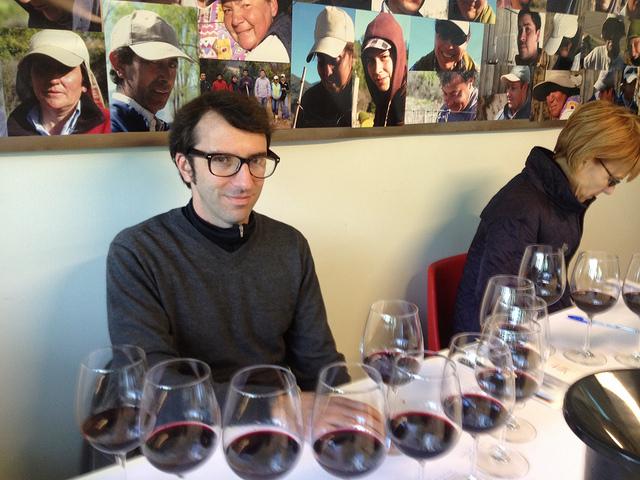How many people are in the picture?
Quick response, please. 2. How many real people are in the picture?
Short answer required. 2. Is this wine tasting?
Keep it brief. Yes. 